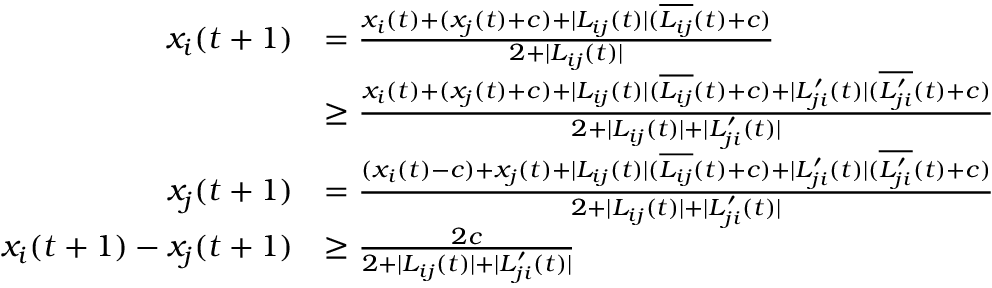Convert formula to latex. <formula><loc_0><loc_0><loc_500><loc_500>\begin{array} { r l } { x _ { i } ( t + 1 ) } & { = \frac { x _ { i } ( t ) + ( x _ { j } ( t ) + c ) + | L _ { i j } ( t ) | ( \overline { { L _ { i j } } } ( t ) + c ) } { 2 + | L _ { i j } ( t ) | } } \\ & { \geq \frac { x _ { i } ( t ) + ( x _ { j } ( t ) + c ) + | L _ { i j } ( t ) | ( \overline { { L _ { i j } } } ( t ) + c ) + | L _ { j i } ^ { \prime } ( t ) | ( \overline { { L _ { j i } ^ { \prime } } } ( t ) + c ) } { 2 + | L _ { i j } ( t ) | + | L _ { j i } ^ { \prime } ( t ) | } } \\ { x _ { j } ( t + 1 ) } & { = \frac { ( x _ { i } ( t ) - c ) + x _ { j } ( t ) + | L _ { i j } ( t ) | ( \overline { { L _ { i j } } } ( t ) + c ) + | L _ { j i } ^ { \prime } ( t ) | ( \overline { { L _ { j i } ^ { \prime } } } ( t ) + c ) } { 2 + | L _ { i j } ( t ) | + | L _ { j i } ^ { \prime } ( t ) | } } \\ { x _ { i } ( t + 1 ) - x _ { j } ( t + 1 ) } & { \geq \frac { 2 c } { 2 + | L _ { i j } ( t ) | + | L _ { j i } ^ { \prime } ( t ) | } } \end{array}</formula> 